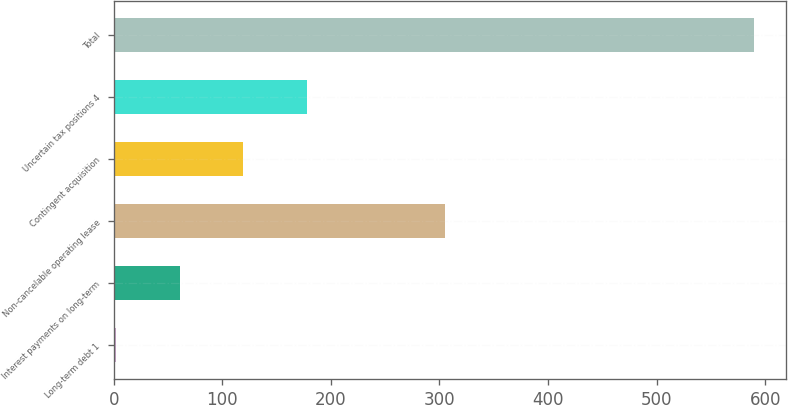Convert chart. <chart><loc_0><loc_0><loc_500><loc_500><bar_chart><fcel>Long-term debt 1<fcel>Interest payments on long-term<fcel>Non-cancelable operating lease<fcel>Contingent acquisition<fcel>Uncertain tax positions 4<fcel>Total<nl><fcel>1.8<fcel>60.61<fcel>305.5<fcel>119.42<fcel>178.23<fcel>589.9<nl></chart> 